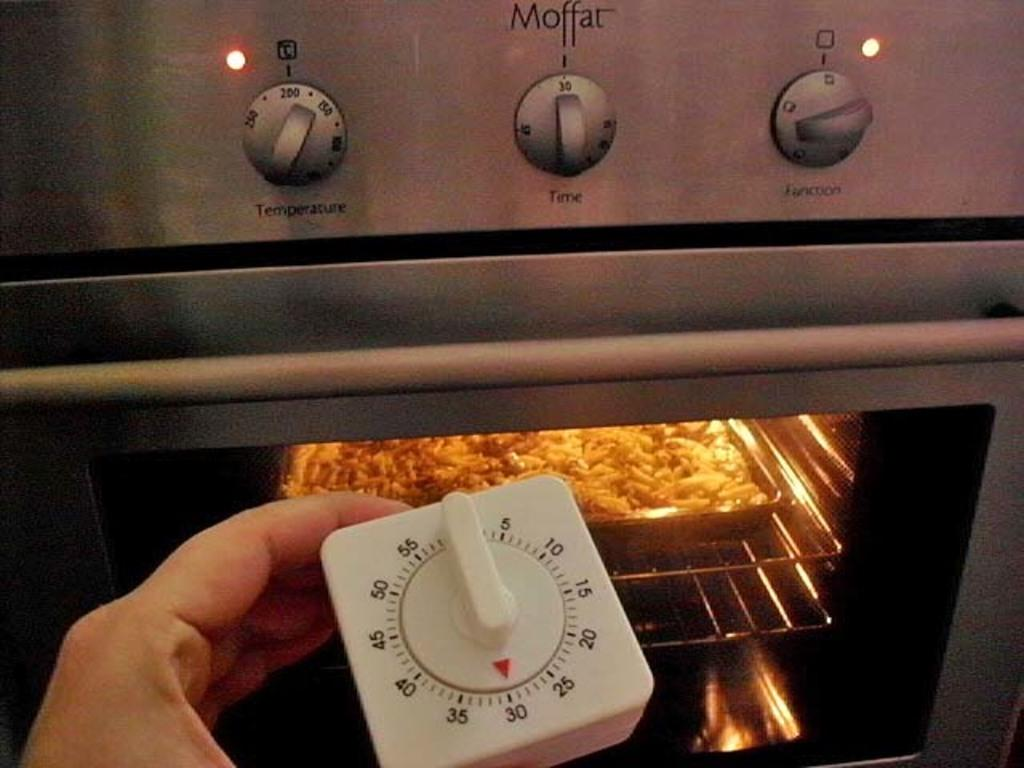What is the person in the image holding? The person in the image is holding a remote. What can be seen inside the appliance in the image? There is a food item in a microwave oven. What is written on the microwave oven? There are some text written on the microwave oven. What type of controls are visible in the image? There are switches visible in the image. What type of religious symbol can be seen on the food item in the image? There is no religious symbol present on the food item in the image. What type of produce is visible in the image? There is no produce visible in the image; it features a food item in a microwave oven. 